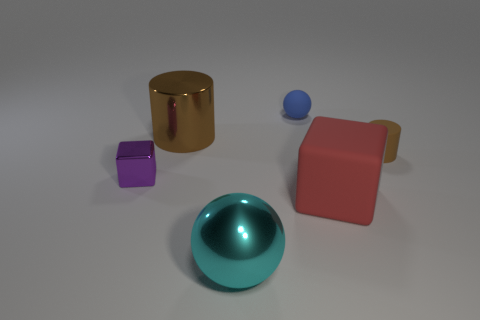Add 3 brown cylinders. How many objects exist? 9 Subtract all balls. How many objects are left? 4 Subtract all large green shiny spheres. Subtract all tiny blocks. How many objects are left? 5 Add 6 tiny brown objects. How many tiny brown objects are left? 7 Add 4 big cyan objects. How many big cyan objects exist? 5 Subtract 0 gray cylinders. How many objects are left? 6 